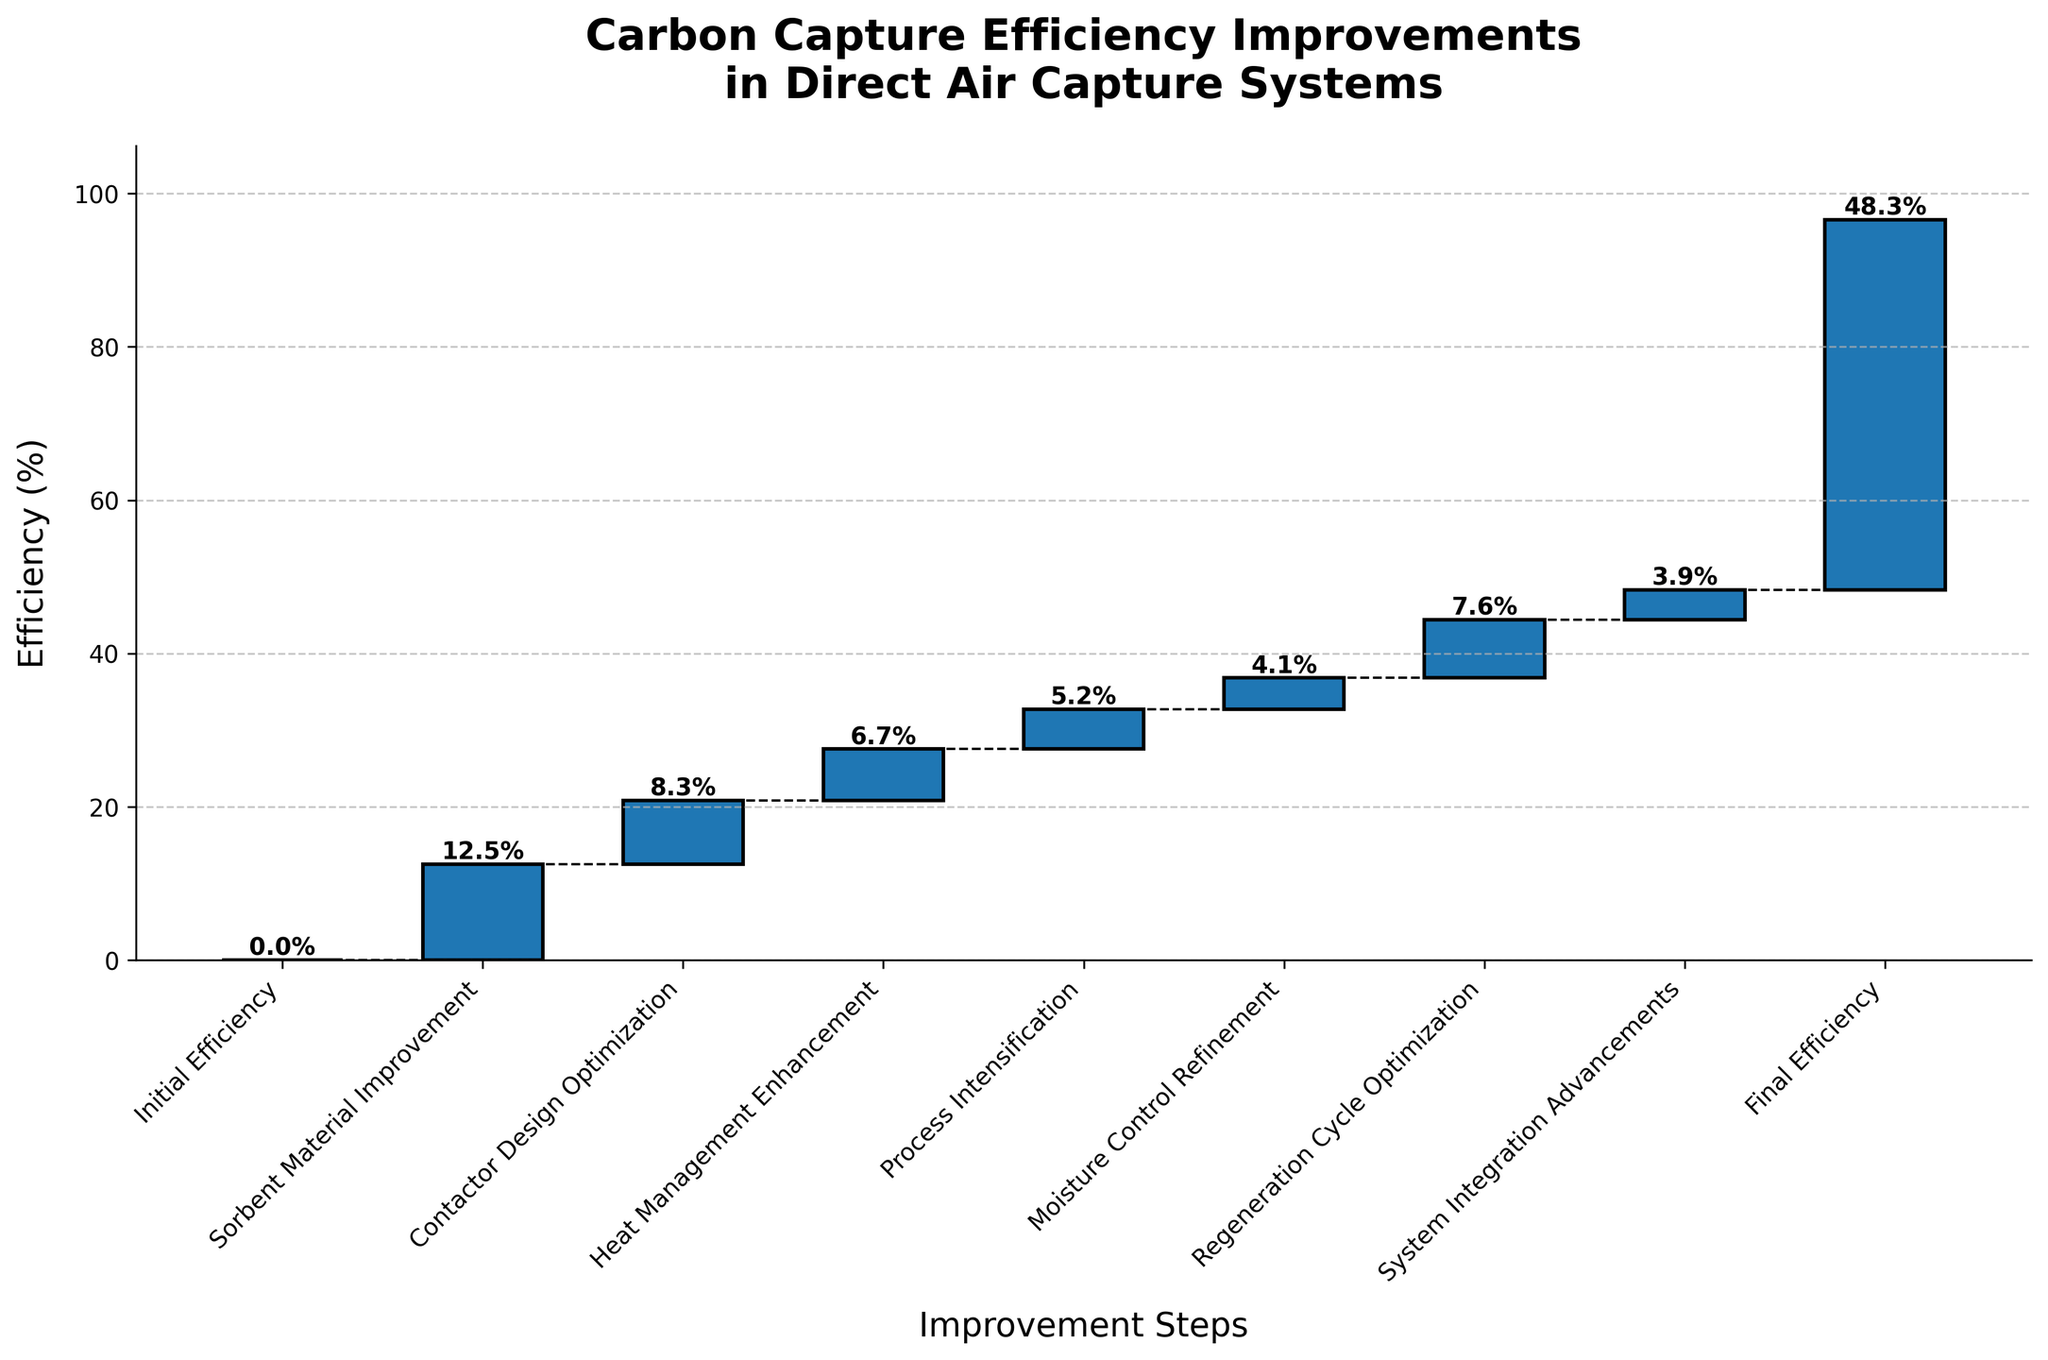What is the initial efficiency in the carbon capture system? The initial efficiency is displayed at the first step of the waterfall chart. It is titled "Initial Efficiency" with a value of 0.
Answer: 0 What efficiency gain is attributed to "Sorbent Material Improvement"? The efficiency gain for "Sorbent Material Improvement" is shown as one of the steps in the chart. It lists a value of 12.5%.
Answer: 12.5% Which step contributes the most to the overall efficiency improvement? By comparing the values for each step, the largest value is for "Sorbent Material Improvement" with 12.5%.
Answer: Sorbent Material Improvement What is the total efficiency improvement from "Heat Management Enhancement" and "Contactor Design Optimization"? Add the values of "Heat Management Enhancement" (6.7%) and "Contactor Design Optimization" (8.3%). The sum is 6.7 + 8.3 = 15%.
Answer: 15% How much does "Moisture Control Refinement" contribute to the efficiency improvement? The value for "Moisture Control Refinement" is listed as 4.1% in the waterfall chart.
Answer: 4.1% What is the difference in efficiency improvement between "Process Intensification" and "System Integration Advancements"? Subtract the value of "System Integration Advancements" (3.9%) from "Process Intensification" (5.2%). The difference is 5.2 - 3.9 = 1.3%.
Answer: 1.3% What is the cumulative efficiency just before the final step? To find the cumulative efficiency just before the final step, sum up all values except "Final Efficiency": 0 + 12.5 + 8.3 + 6.7 + 5.2 + 4.1 + 7.6 + 3.9 = 48.3%.
Answer: 48.3% Compare "Regeneration Cycle Optimization" and "System Integration Advancements" in terms of efficiency contribution. Which step has a higher value and by how much? "Regeneration Cycle Optimization" contributes 7.6%, and "System Integration Advancements" contributes 3.9%. The difference is 7.6 - 3.9 = 3.7%.
Answer: Regeneration Cycle Optimization by 3.7% What is the final efficiency after all improvements? The final efficiency is indicated at the last step titled "Final Efficiency," showing a value of 48.3%.
Answer: 48.3% What is the average efficiency improvement per step not including the initial and final efficiencies? Sum the values of all intermediate steps and divide by the number of these steps. Sum: 12.5 + 8.3 + 6.7 + 5.2 + 4.1 + 7.6 + 3.9 = 48.3%. Number of steps: 7. Average = 48.3 / 7 ≈ 6.9%.
Answer: 6.9% 